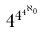<formula> <loc_0><loc_0><loc_500><loc_500>4 ^ { 4 ^ { 4 ^ { \aleph _ { 0 } } } }</formula> 